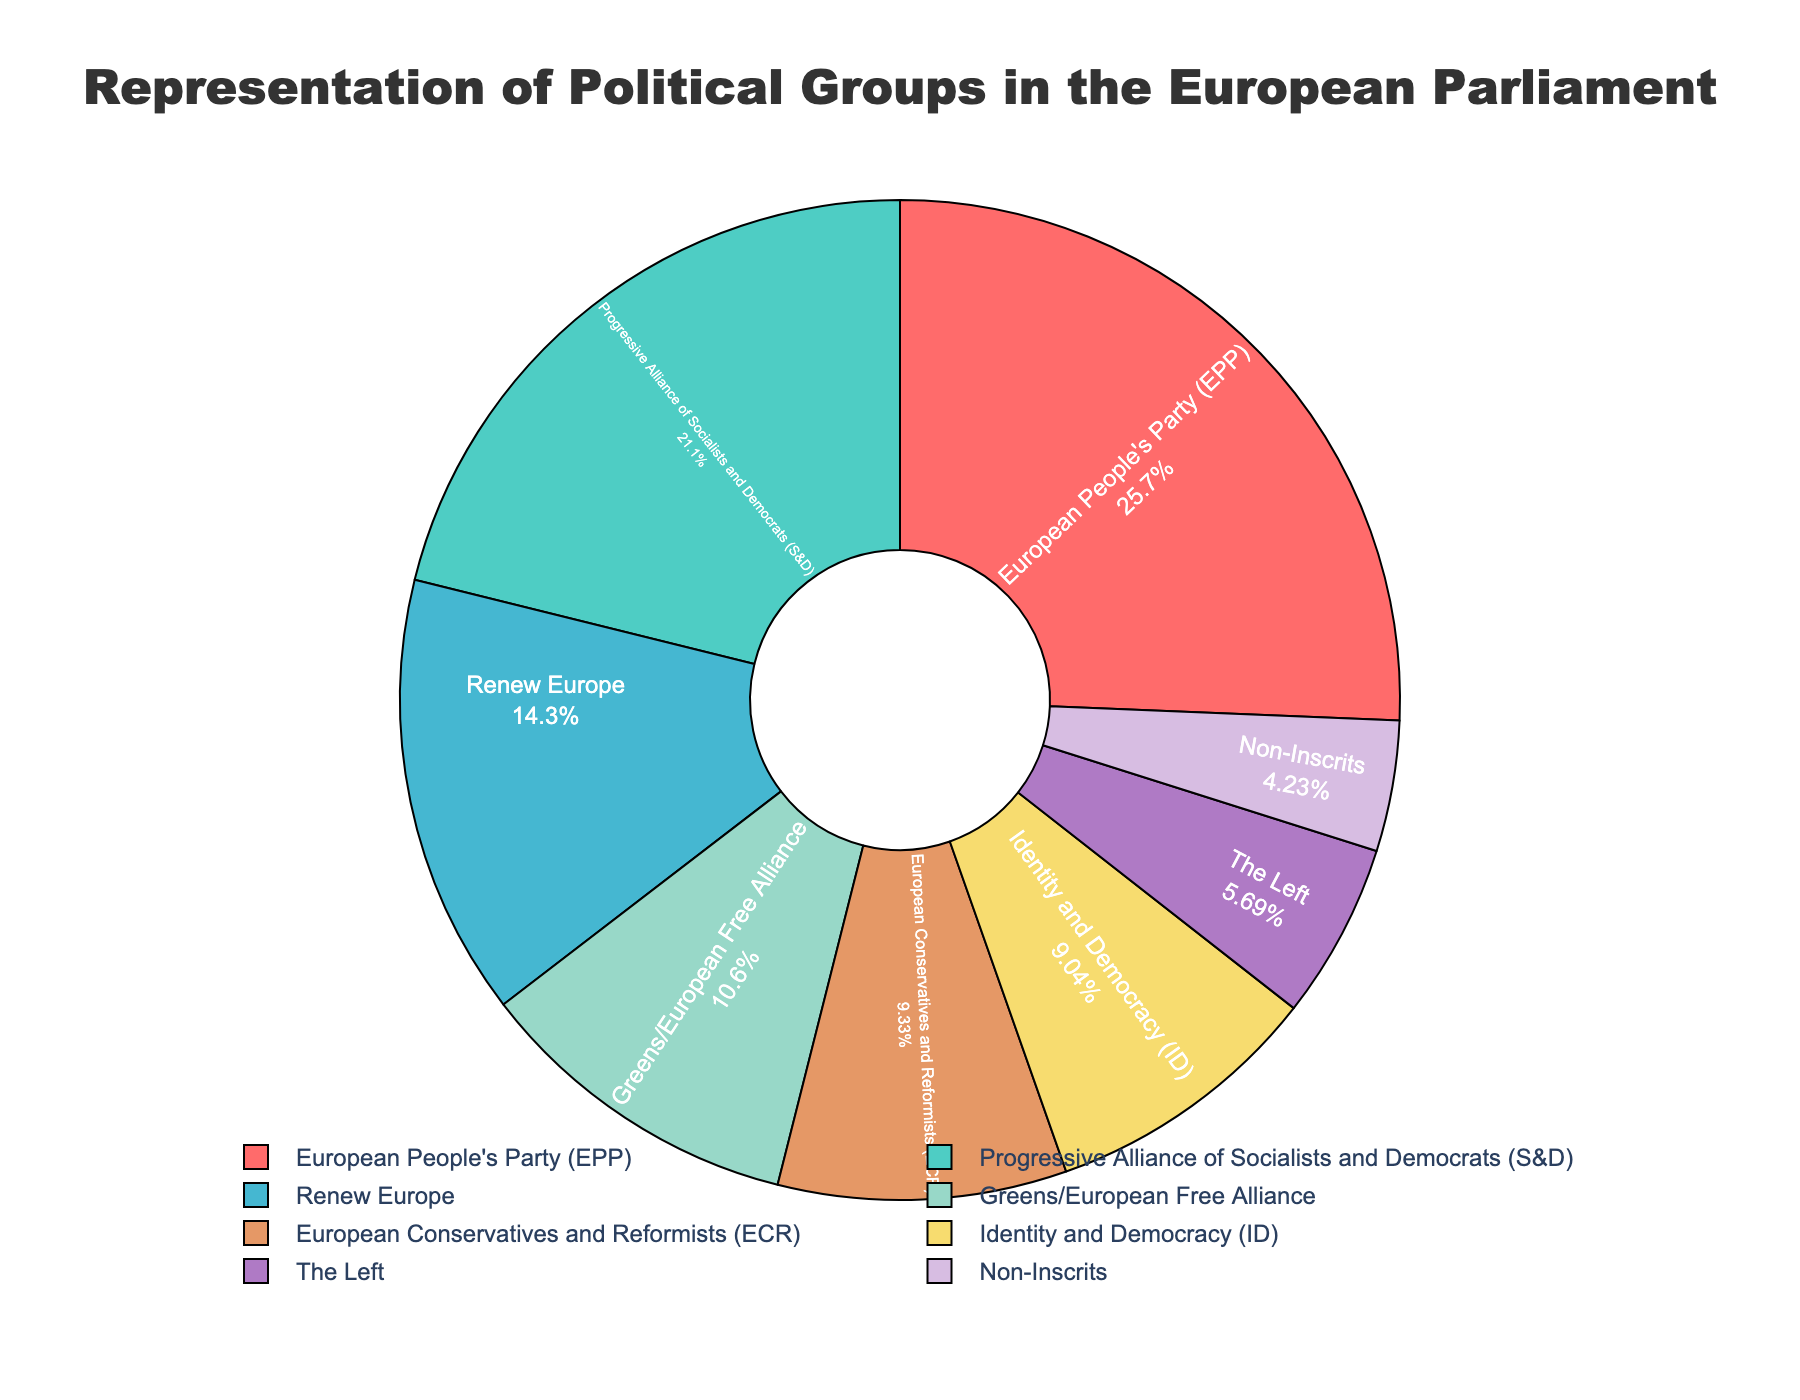Which political group has the highest number of seats? Look at the section with the largest area and note the label and the corresponding value. The European People's Party (EPP) has the largest portion of the pie chart with 176 seats.
Answer: European People's Party (EPP) What is the combined percentage of seats held by Renew Europe and the Greens/European Free Alliance? Identify the individual percentages for Renew Europe and Greens/European Free Alliance, then sum them up to get the combined percentage.
Answer: 13.82% (Renew Europe: 13.51% + Greens/European Free Alliance: 10.12%) How many more seats does the European People's Party (EPP) have compared to the Non-Inscrits? Subtract the number of seats of Non-Inscrits (29) from those of the European People's Party (EPP) (176). 176 - 29 = 147.
Answer: 147 Which political groups have fewer than 50 seats? Identify all political groups whose seat counts are less than 50. The groups are The Left (39) and Non-Inscrits (29).
Answer: The Left, Non-Inscrits What is the percentage of seats occupied by the Progressive Alliance of Socialists and Democrats (S&D)? Locate the portion of the pie chart representing the Progressive Alliance of Socialists and Democrats and note the percentage displayed.
Answer: 19.91% What’s the total number of seats represented in the figure? Sum all seat values: 176 (EPP) + 145 (S&D) + 98 (Renew Europe) + 73 (Greens/EFA) + 62 (ID) + 64 (ECR) + 39 (The Left) + 29 (Non-Inscrits).
Answer: 686 How many seats separate the Identity and Democracy (ID) group from the European Conservatives and Reformists (ECR)? Subtract the number of seats of ID (62) from those of ECR (64). 64 - 62 = 2.
Answer: 2 Which political group is represented by a light blue color? Refer to the visual representation and identify the group corresponding to the light blue section of the pie chart.
Answer: Renew Europe 